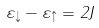Convert formula to latex. <formula><loc_0><loc_0><loc_500><loc_500>\varepsilon _ { \downarrow } - \varepsilon _ { \uparrow } = 2 J</formula> 